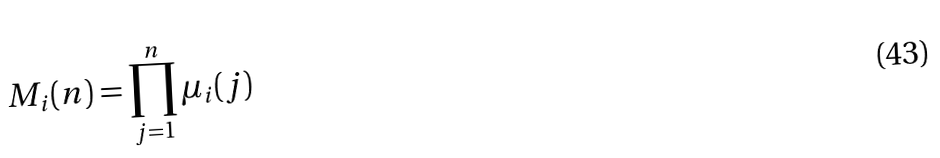Convert formula to latex. <formula><loc_0><loc_0><loc_500><loc_500>M _ { i } ( n ) = \prod _ { j = 1 } ^ { n } \mu _ { i } ( j )</formula> 